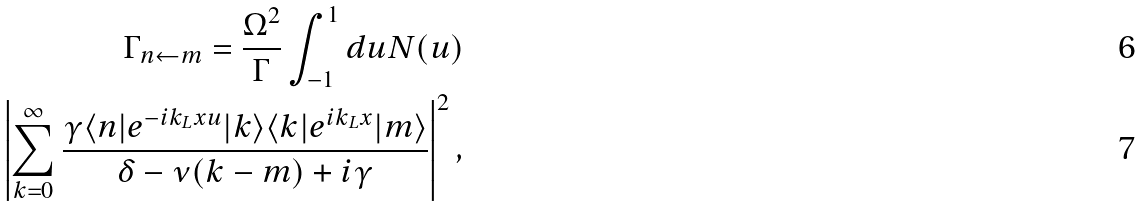<formula> <loc_0><loc_0><loc_500><loc_500>\Gamma _ { n \leftarrow m } = \frac { \Omega ^ { 2 } } { \Gamma } \int _ { - 1 } ^ { 1 } d u N ( u ) \\ \left | \sum _ { k = 0 } ^ { \infty } \frac { \gamma \langle n | e ^ { - i k _ { L } x u } | k \rangle \langle k | e ^ { i k _ { L } x } | m \rangle } { \delta - \nu ( k - m ) + i \gamma } \right | ^ { 2 } ,</formula> 